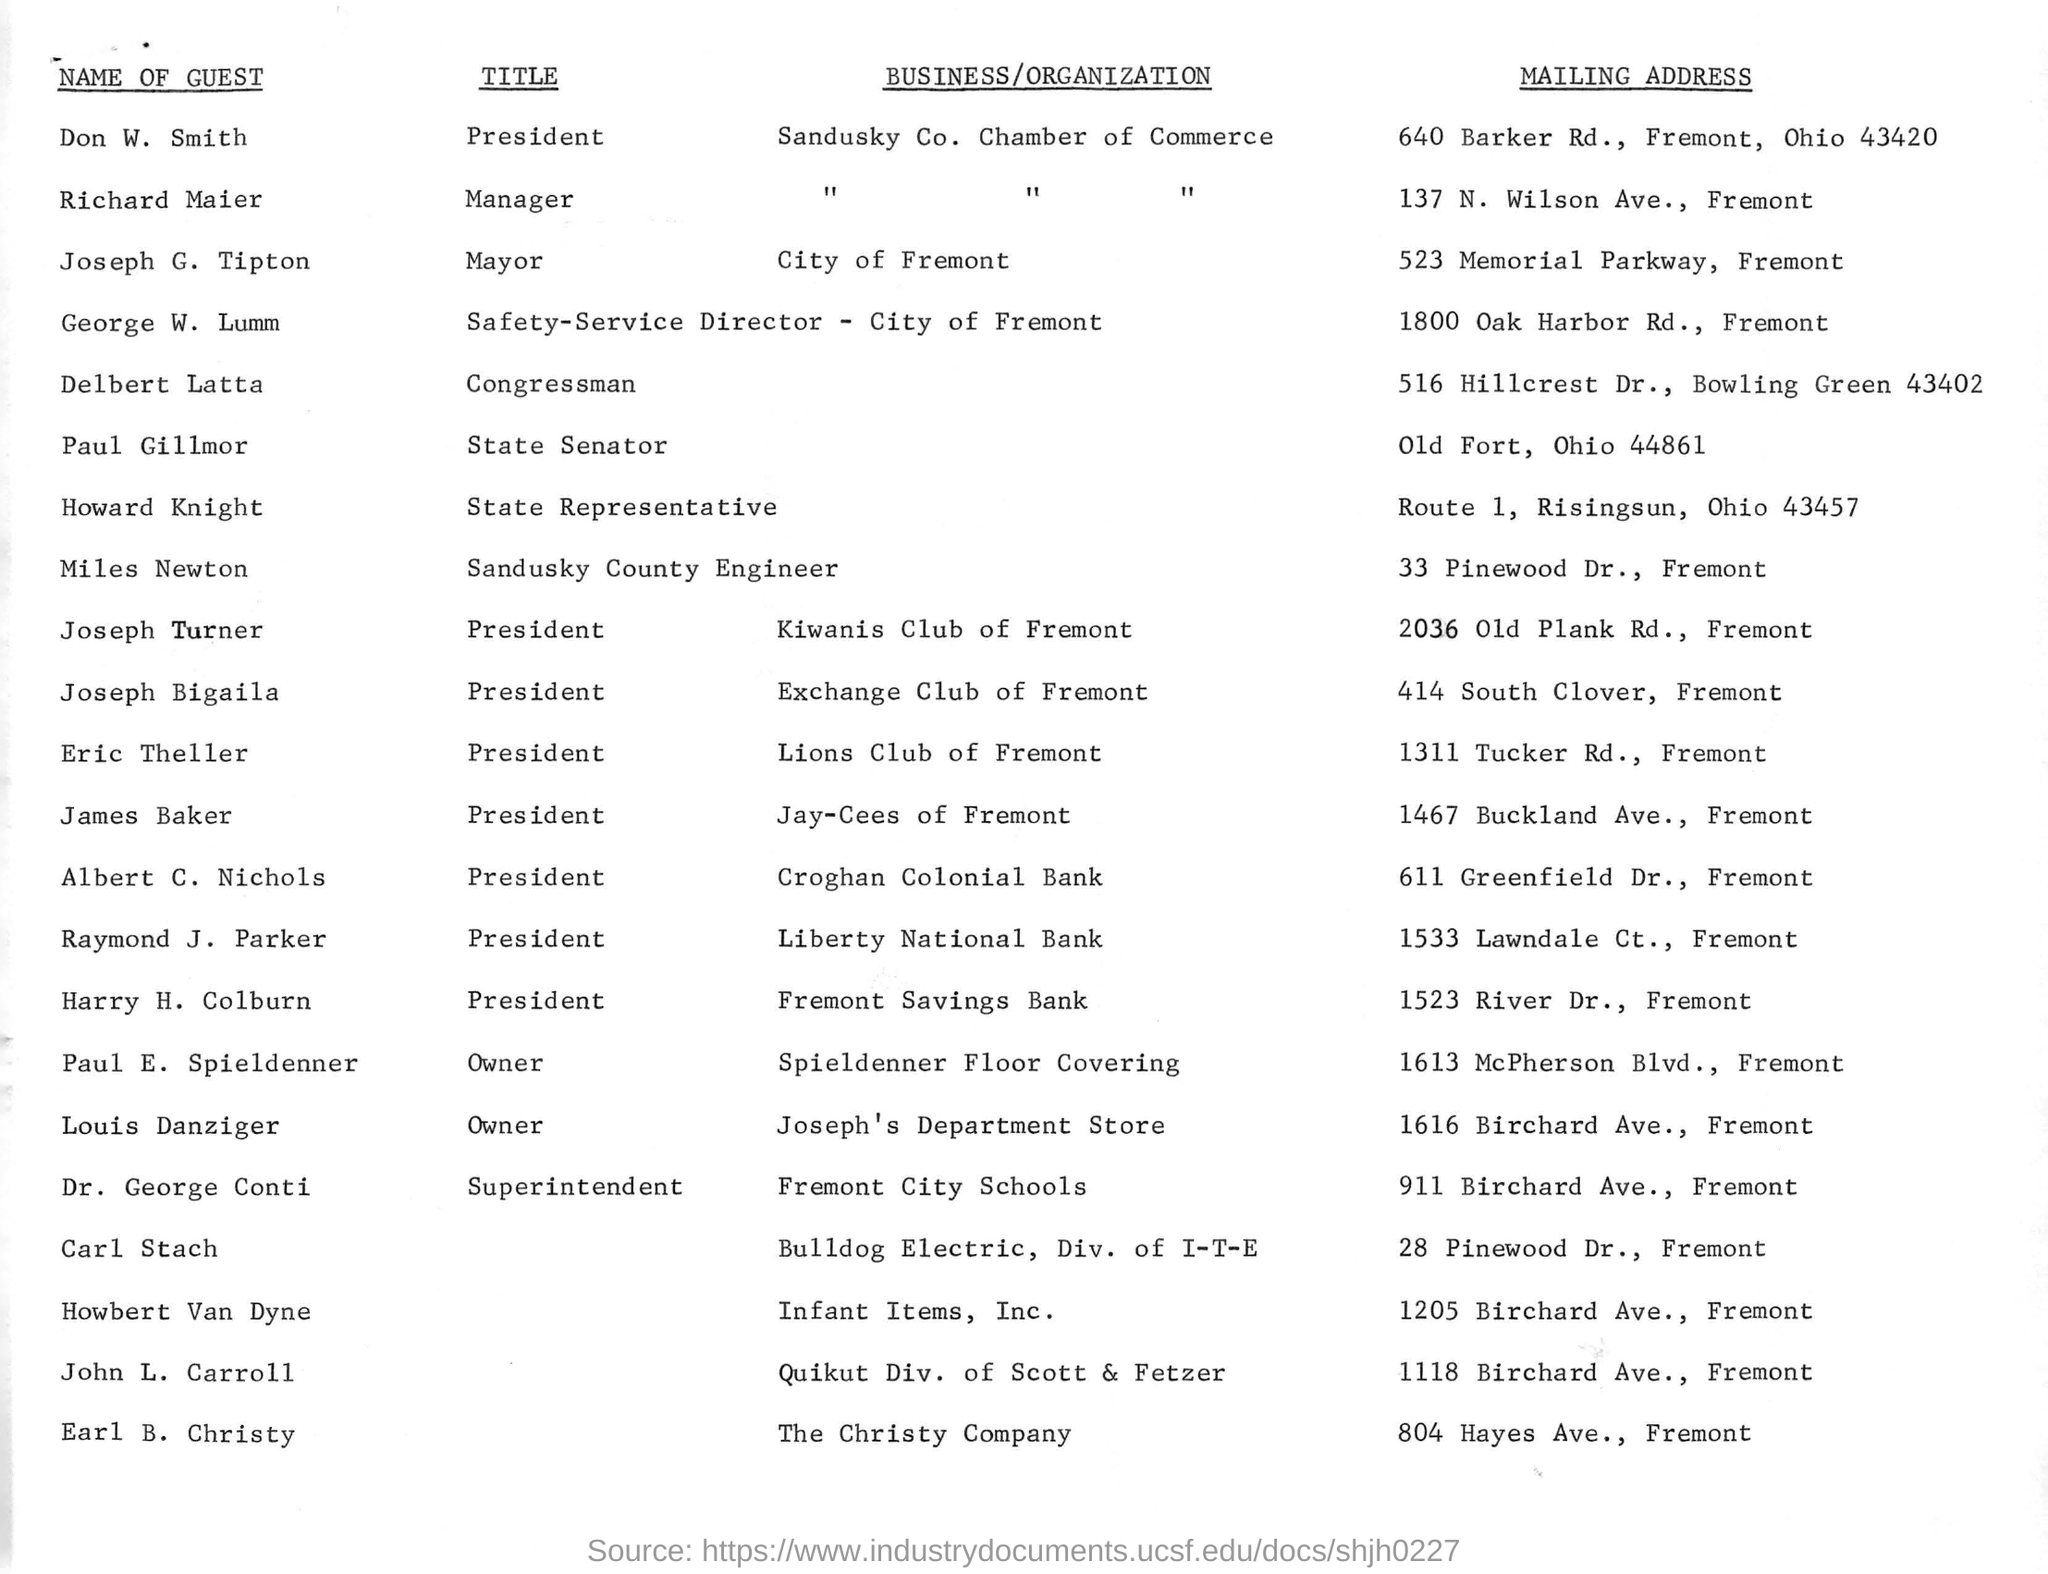Identify some key points in this picture. Raymond J. Parker is the president of a certain entity. The Christy Company is located in Fremont. The mayor of the City of Fremont is Joseph G. Tipton. Louis Danziger owns Joseph's Department Store. 